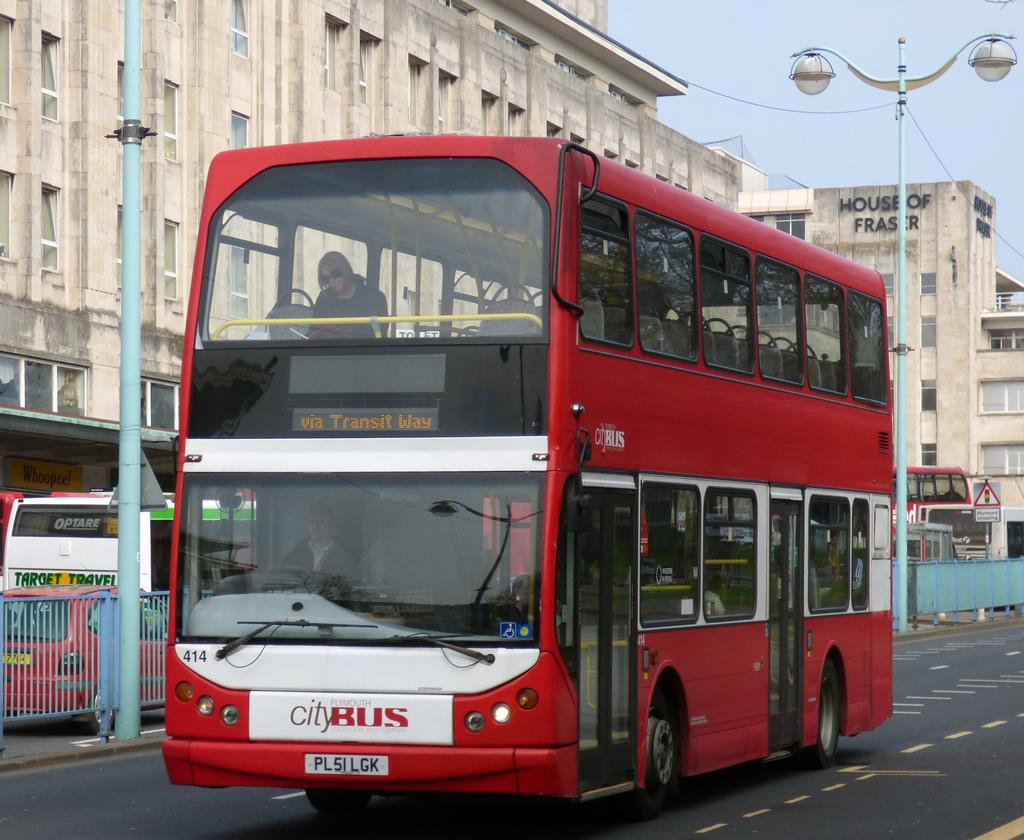<image>
Give a short and clear explanation of the subsequent image. A red double decker city bus is via Transit Way. 